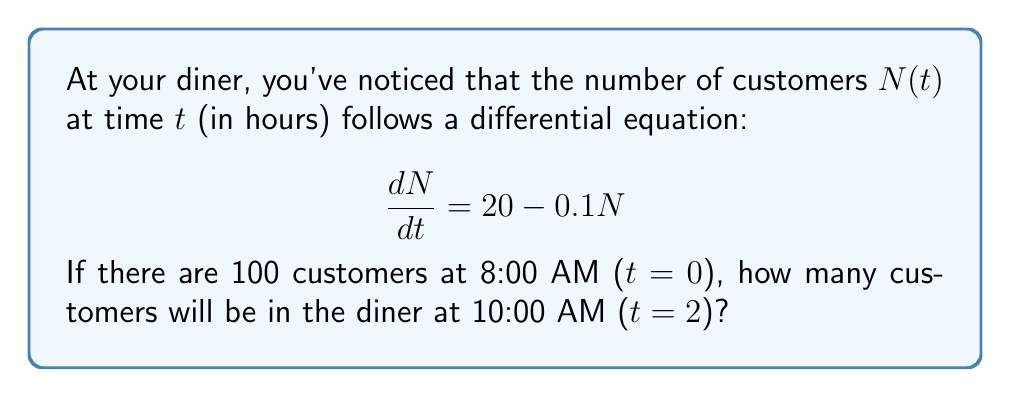Can you answer this question? Let's solve this step-by-step:

1) The given differential equation is:
   $$\frac{dN}{dt} = 20 - 0.1N$$

2) This is a linear first-order differential equation. The general solution is:
   $$N(t) = N_e + (N_0 - N_e)e^{-kt}$$
   where $N_e$ is the equilibrium value, $N_0$ is the initial value, and $k$ is the rate constant.

3) Find the equilibrium value $N_e$ by setting $\frac{dN}{dt} = 0$:
   $$0 = 20 - 0.1N_e$$
   $$N_e = 200$$

4) We know $k = 0.1$ and $N_0 = 100$. Substituting into the general solution:
   $$N(t) = 200 + (100 - 200)e^{-0.1t}$$
   $$N(t) = 200 - 100e^{-0.1t}$$

5) To find $N(2)$, substitute $t=2$:
   $$N(2) = 200 - 100e^{-0.1(2)}$$
   $$N(2) = 200 - 100e^{-0.2}$$
   $$N(2) \approx 181.87$$

6) Rounding to the nearest whole number (as we can't have fractional customers):
   $$N(2) \approx 182$$
Answer: 182 customers 